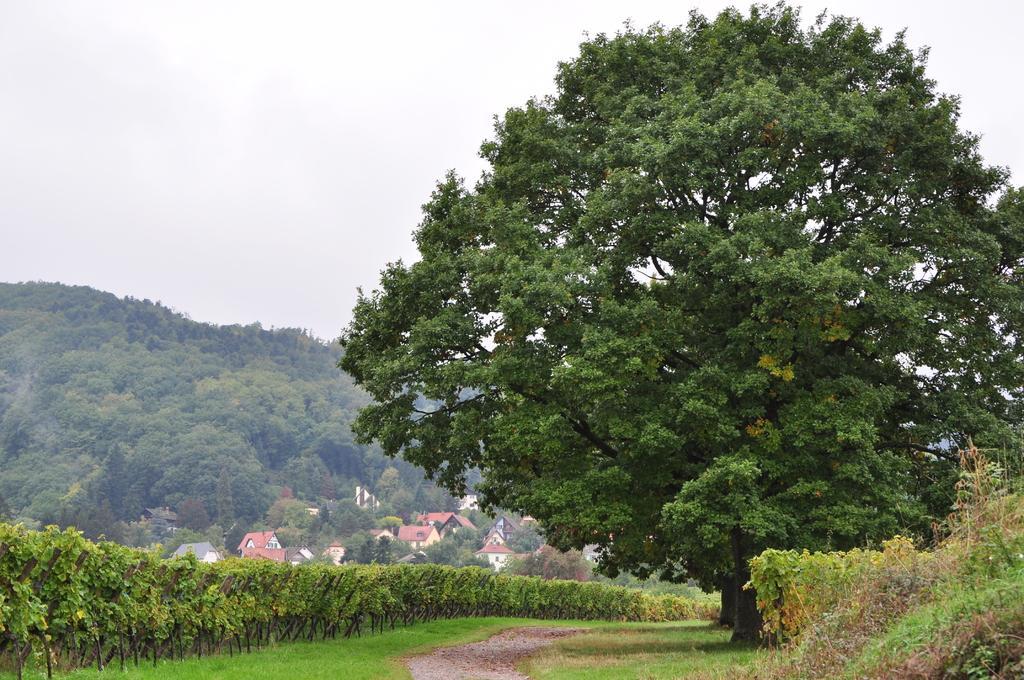Describe this image in one or two sentences. In this image there are trees, plants at the bottom there is grass and walkway and in the background there are some trees, houses, buildings. And at the top there is sky. 